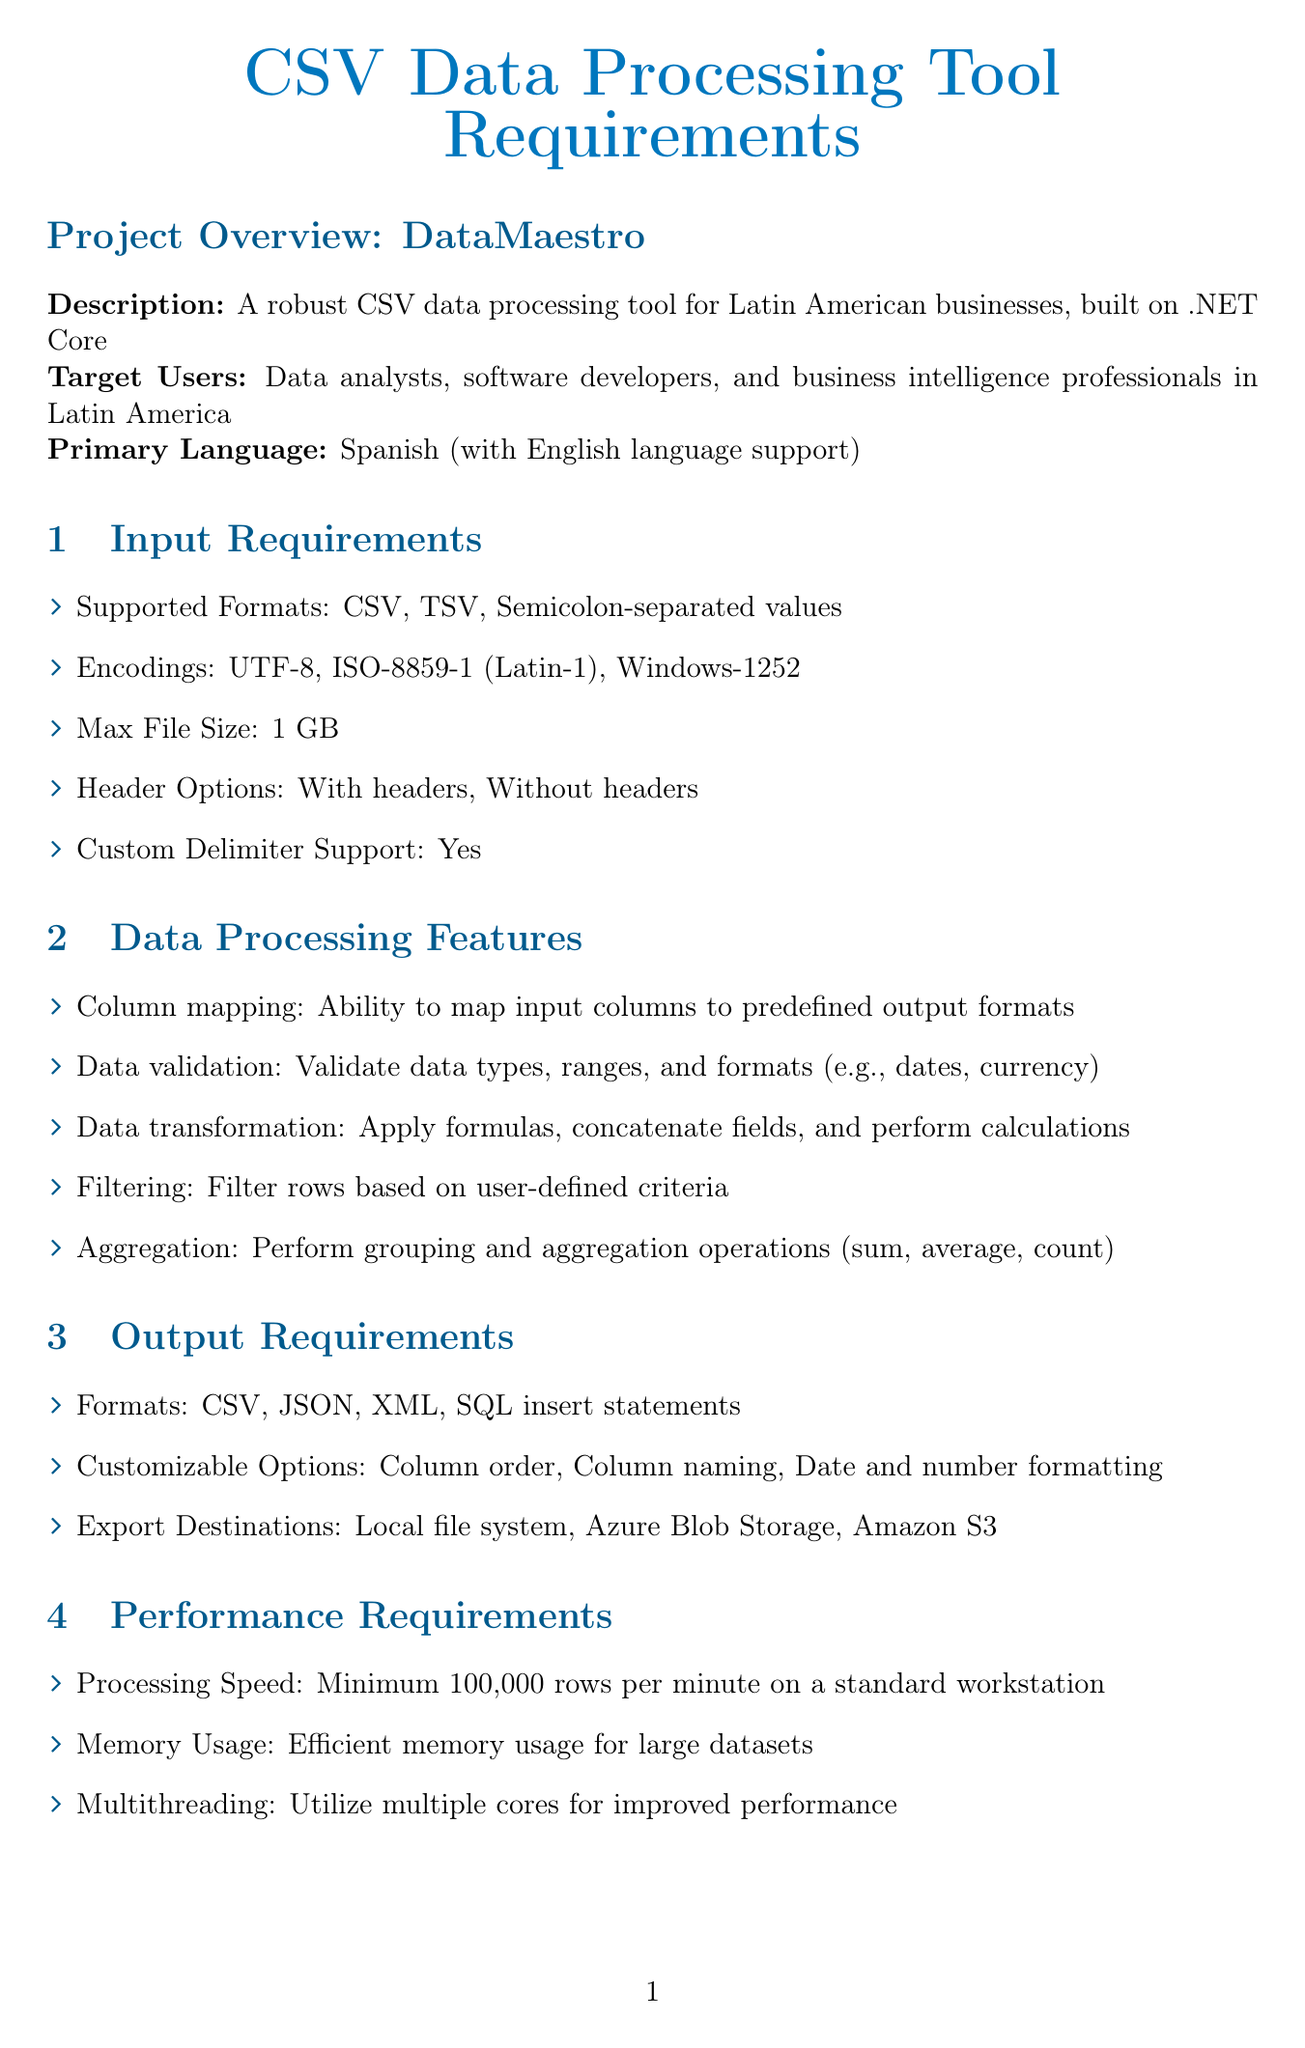what is the project name? The project name is specified in the document, which is DataMaestro.
Answer: DataMaestro what are the supported input formats? The supported input formats are listed in the document. They include CSV, TSV, and Semicolon-separated values.
Answer: CSV, TSV, Semicolon-separated values what is the maximum file size allowed? The maximum file size specified for the input is mentioned in the document.
Answer: 1 GB which programming language is used for development? The programming language for the project is indicated in the technical specifications section of the document.
Answer: C# what minimum processing speed is required? The document specifies the processing speed requirement for the tool, which is measured in rows per minute.
Answer: Minimum 100,000 rows per minute what are the encryption standards mentioned? The document indicates the encryption method used for data protection.
Answer: AES-256 what are the target platforms for the tool? The target platforms are clearly stated in the technical specifications section of the document.
Answer: Windows, macOS, Linux what type of user authentication is supported? The user authentication method supported is detailed in the security requirements section.
Answer: OAuth 2.0 what is a unique feature of the tool's flexibility in output? The document describes customizable options for output in the output requirements section.
Answer: Column order, Column naming, Date and number formatting 